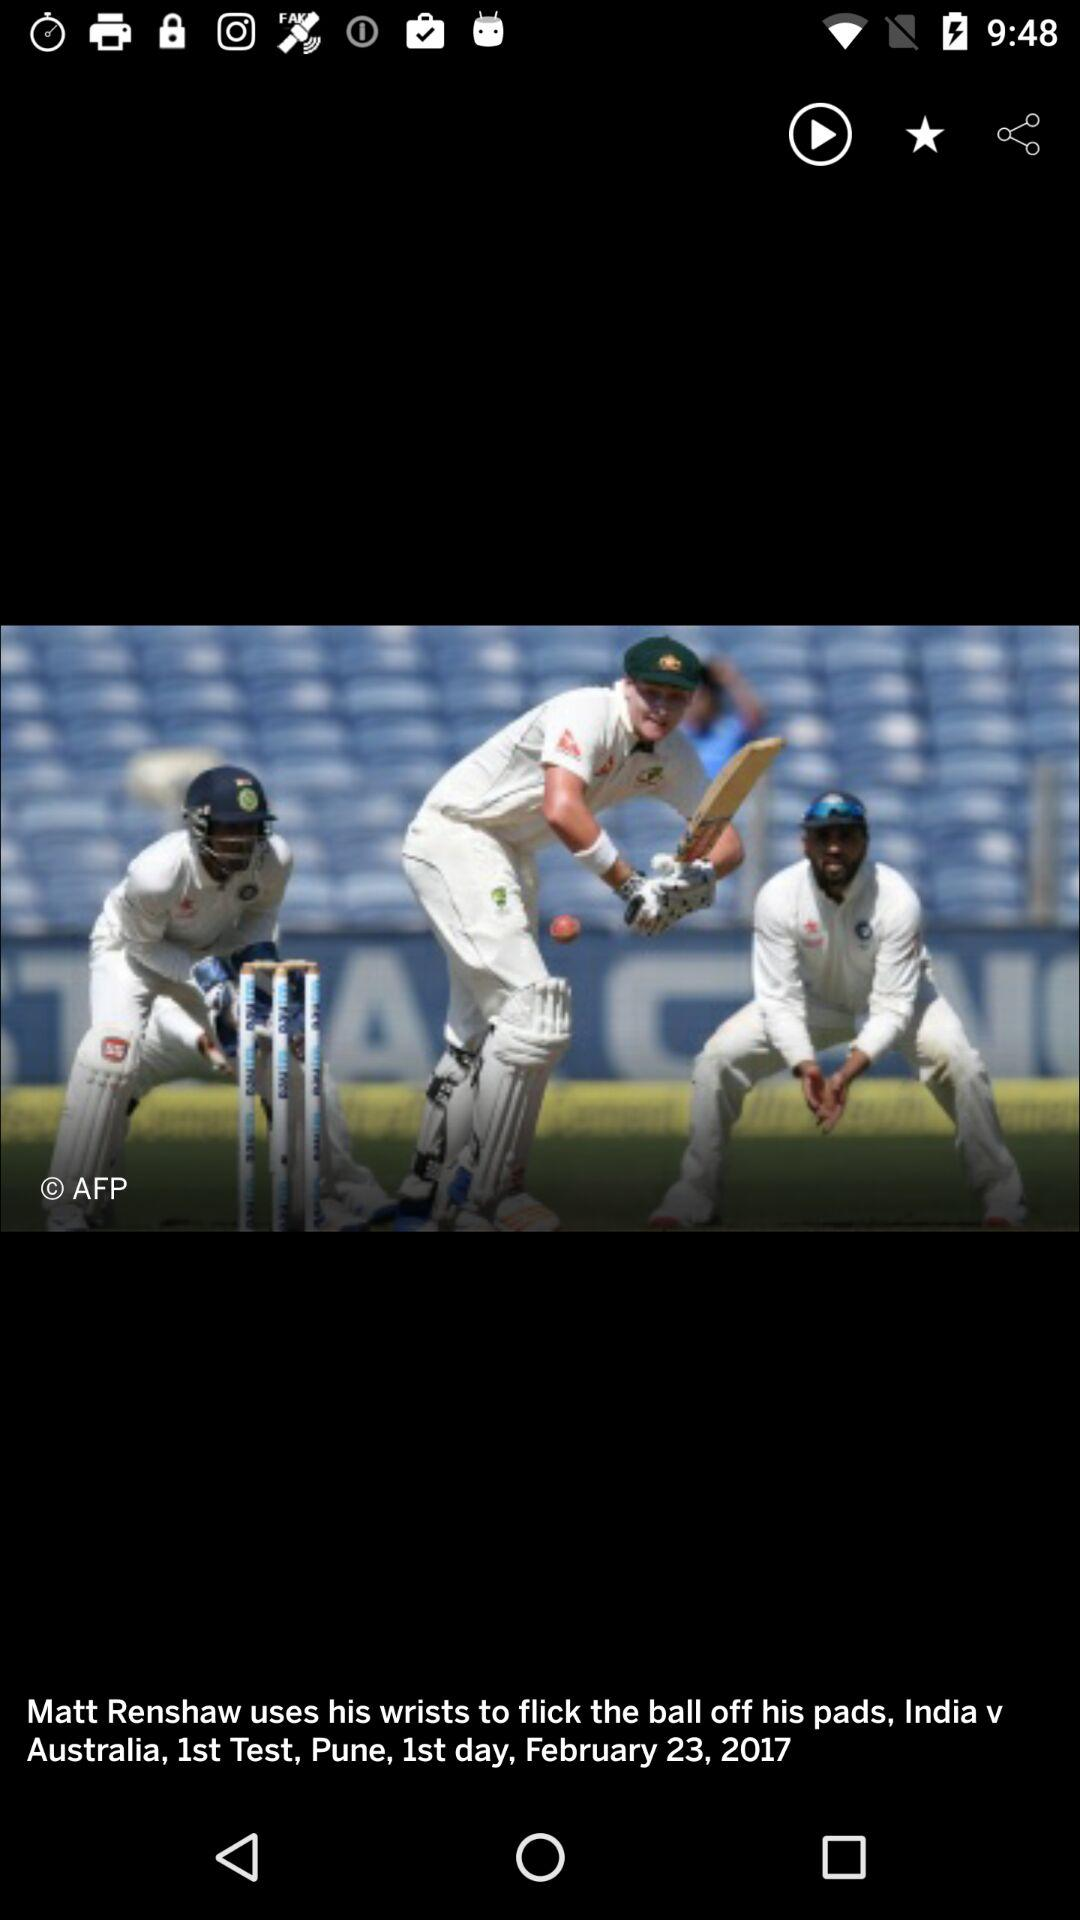What is the batsman name? The batsman name is Matt Renshaw. 